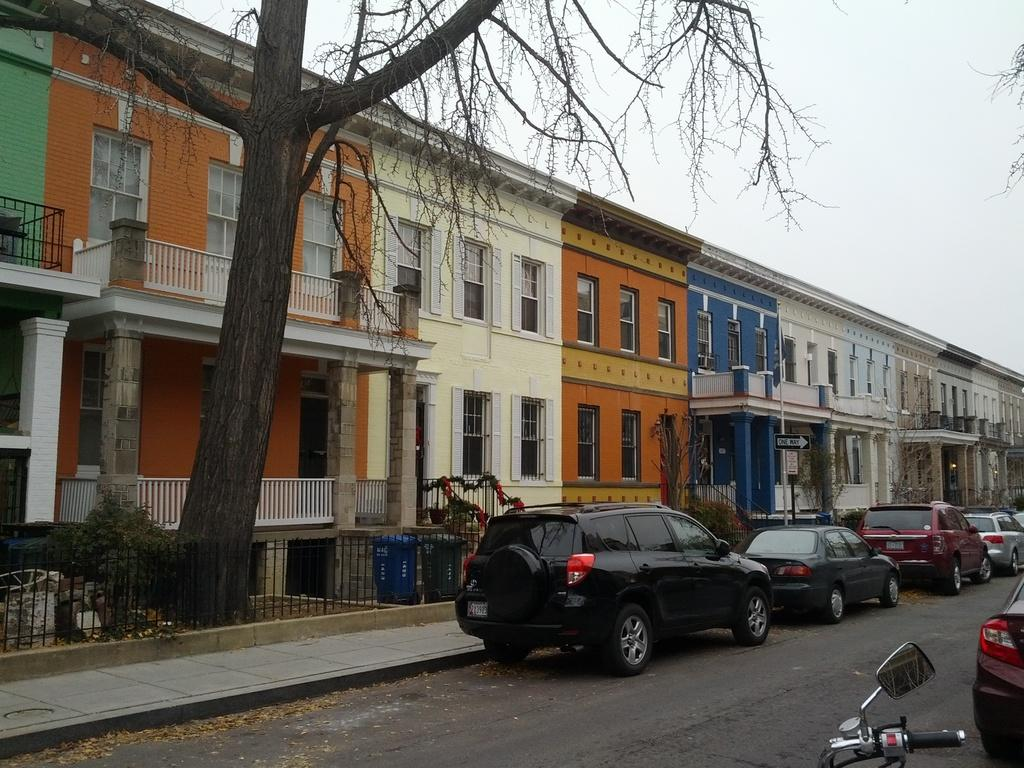What type of vehicles are parked on the road in the image? There are cars parked on the road in the image. Where are the cars located in relation to the buildings? The cars are in front of the buildings. What can be seen in the image besides the cars and buildings? There are trees visible in the image. What is the purpose of the sign board on a pole in the image? The purpose of the sign board is to provide information or directions. What other mode of transportation can be seen in the image? A motorbike is present in the image. What is visible in the background of the image? The sky is visible in the background. What type of seafood is being served for dinner in the image? There is no seafood or dinner present in the image; it features cars parked on the road in front of buildings. What is the width of the sidewalk in the image? There is no sidewalk present in the image; it features cars parked on the road in front of buildings. 